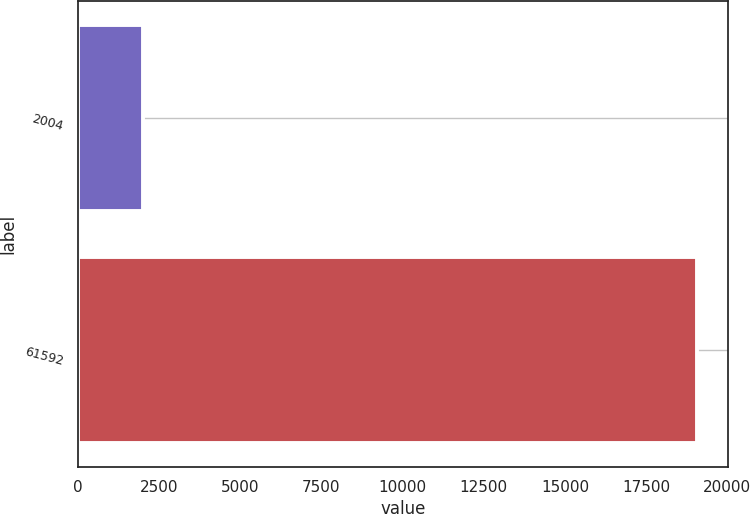Convert chart. <chart><loc_0><loc_0><loc_500><loc_500><bar_chart><fcel>2004<fcel>61592<nl><fcel>2003<fcel>19064<nl></chart> 